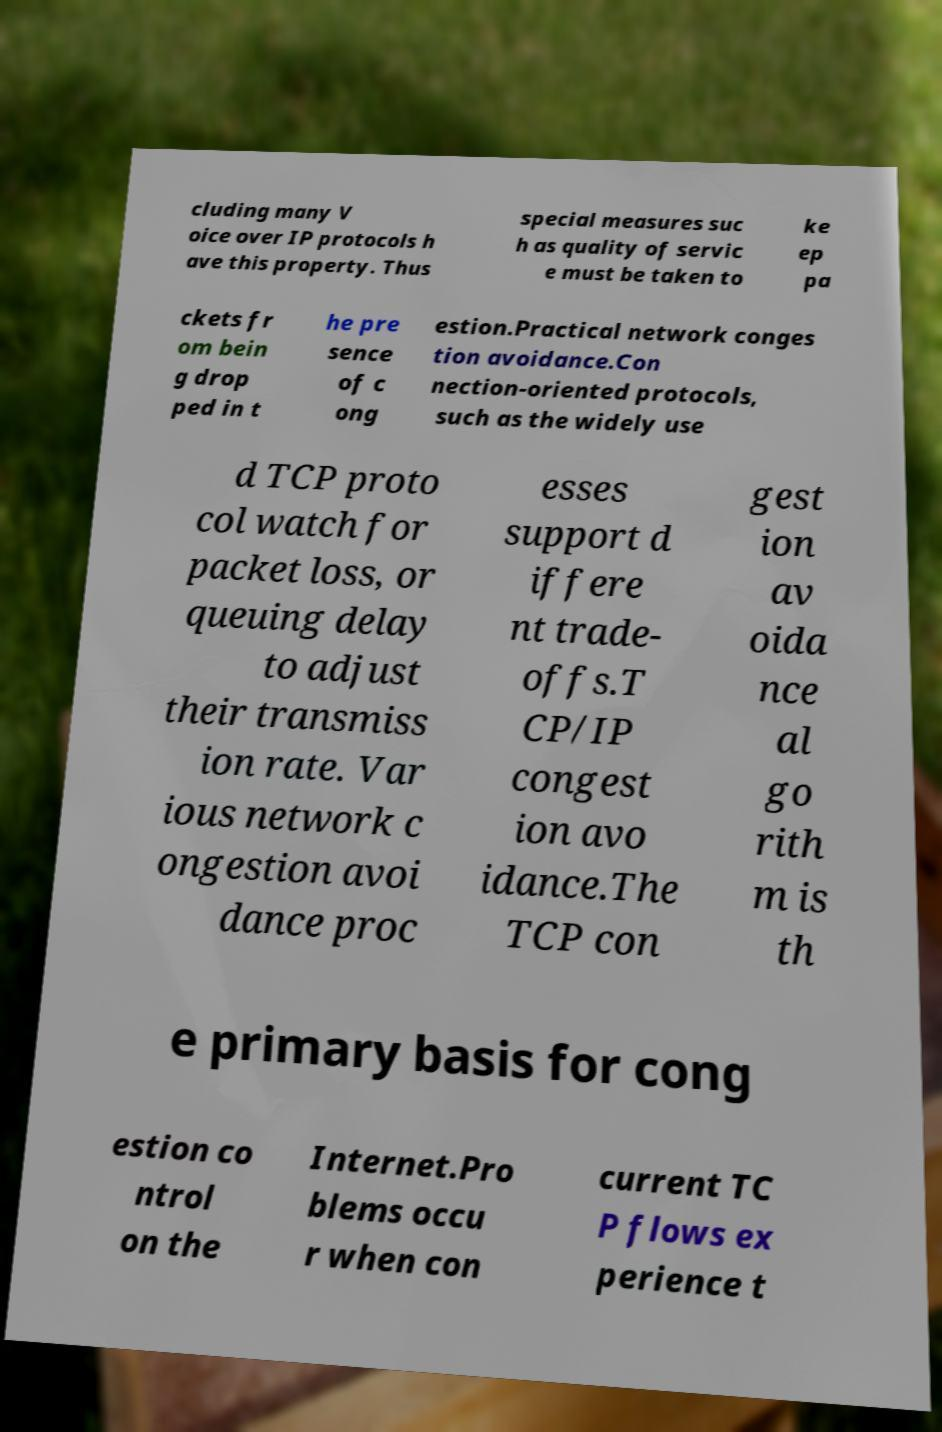Can you accurately transcribe the text from the provided image for me? cluding many V oice over IP protocols h ave this property. Thus special measures suc h as quality of servic e must be taken to ke ep pa ckets fr om bein g drop ped in t he pre sence of c ong estion.Practical network conges tion avoidance.Con nection-oriented protocols, such as the widely use d TCP proto col watch for packet loss, or queuing delay to adjust their transmiss ion rate. Var ious network c ongestion avoi dance proc esses support d iffere nt trade- offs.T CP/IP congest ion avo idance.The TCP con gest ion av oida nce al go rith m is th e primary basis for cong estion co ntrol on the Internet.Pro blems occu r when con current TC P flows ex perience t 